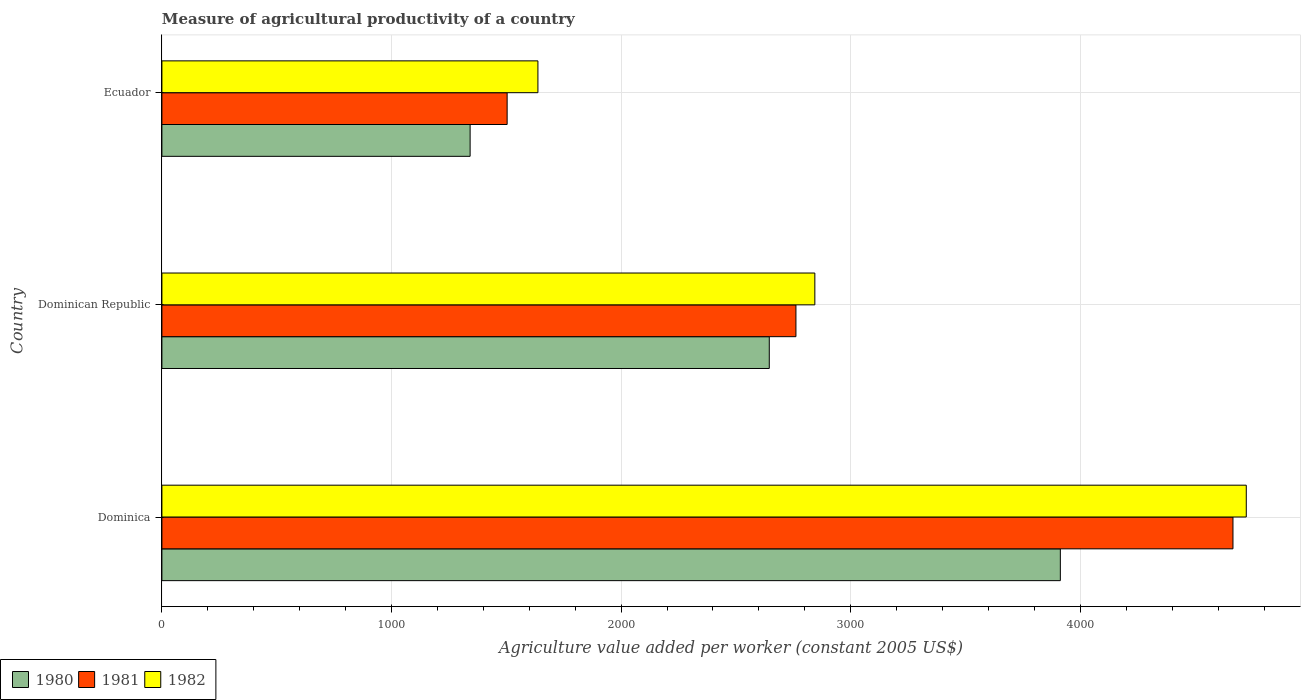How many groups of bars are there?
Offer a very short reply. 3. Are the number of bars on each tick of the Y-axis equal?
Provide a succinct answer. Yes. How many bars are there on the 2nd tick from the bottom?
Provide a short and direct response. 3. What is the label of the 3rd group of bars from the top?
Ensure brevity in your answer.  Dominica. What is the measure of agricultural productivity in 1981 in Ecuador?
Provide a succinct answer. 1503.63. Across all countries, what is the maximum measure of agricultural productivity in 1982?
Provide a succinct answer. 4722.8. Across all countries, what is the minimum measure of agricultural productivity in 1980?
Keep it short and to the point. 1342.41. In which country was the measure of agricultural productivity in 1982 maximum?
Offer a terse response. Dominica. In which country was the measure of agricultural productivity in 1980 minimum?
Give a very brief answer. Ecuador. What is the total measure of agricultural productivity in 1982 in the graph?
Offer a very short reply. 9204.29. What is the difference between the measure of agricultural productivity in 1980 in Dominica and that in Ecuador?
Offer a terse response. 2570.58. What is the difference between the measure of agricultural productivity in 1982 in Dominica and the measure of agricultural productivity in 1981 in Ecuador?
Make the answer very short. 3219.18. What is the average measure of agricultural productivity in 1982 per country?
Provide a short and direct response. 3068.1. What is the difference between the measure of agricultural productivity in 1982 and measure of agricultural productivity in 1981 in Dominican Republic?
Ensure brevity in your answer.  82.38. What is the ratio of the measure of agricultural productivity in 1981 in Dominica to that in Dominican Republic?
Your answer should be compact. 1.69. Is the measure of agricultural productivity in 1982 in Dominica less than that in Dominican Republic?
Give a very brief answer. No. Is the difference between the measure of agricultural productivity in 1982 in Dominica and Ecuador greater than the difference between the measure of agricultural productivity in 1981 in Dominica and Ecuador?
Offer a terse response. No. What is the difference between the highest and the second highest measure of agricultural productivity in 1980?
Ensure brevity in your answer.  1267.68. What is the difference between the highest and the lowest measure of agricultural productivity in 1981?
Provide a succinct answer. 3161.2. Is the sum of the measure of agricultural productivity in 1981 in Dominican Republic and Ecuador greater than the maximum measure of agricultural productivity in 1980 across all countries?
Your response must be concise. Yes. How many bars are there?
Your response must be concise. 9. How many countries are there in the graph?
Your answer should be very brief. 3. What is the difference between two consecutive major ticks on the X-axis?
Your response must be concise. 1000. Are the values on the major ticks of X-axis written in scientific E-notation?
Your answer should be very brief. No. Does the graph contain grids?
Offer a terse response. Yes. Where does the legend appear in the graph?
Provide a succinct answer. Bottom left. How many legend labels are there?
Keep it short and to the point. 3. What is the title of the graph?
Provide a succinct answer. Measure of agricultural productivity of a country. Does "1983" appear as one of the legend labels in the graph?
Make the answer very short. No. What is the label or title of the X-axis?
Make the answer very short. Agriculture value added per worker (constant 2005 US$). What is the label or title of the Y-axis?
Your answer should be very brief. Country. What is the Agriculture value added per worker (constant 2005 US$) of 1980 in Dominica?
Your answer should be very brief. 3912.99. What is the Agriculture value added per worker (constant 2005 US$) of 1981 in Dominica?
Provide a short and direct response. 4664.83. What is the Agriculture value added per worker (constant 2005 US$) in 1982 in Dominica?
Make the answer very short. 4722.8. What is the Agriculture value added per worker (constant 2005 US$) of 1980 in Dominican Republic?
Make the answer very short. 2645.31. What is the Agriculture value added per worker (constant 2005 US$) of 1981 in Dominican Republic?
Give a very brief answer. 2761.41. What is the Agriculture value added per worker (constant 2005 US$) in 1982 in Dominican Republic?
Offer a terse response. 2843.79. What is the Agriculture value added per worker (constant 2005 US$) in 1980 in Ecuador?
Keep it short and to the point. 1342.41. What is the Agriculture value added per worker (constant 2005 US$) of 1981 in Ecuador?
Keep it short and to the point. 1503.63. What is the Agriculture value added per worker (constant 2005 US$) in 1982 in Ecuador?
Make the answer very short. 1637.69. Across all countries, what is the maximum Agriculture value added per worker (constant 2005 US$) of 1980?
Ensure brevity in your answer.  3912.99. Across all countries, what is the maximum Agriculture value added per worker (constant 2005 US$) in 1981?
Give a very brief answer. 4664.83. Across all countries, what is the maximum Agriculture value added per worker (constant 2005 US$) of 1982?
Provide a short and direct response. 4722.8. Across all countries, what is the minimum Agriculture value added per worker (constant 2005 US$) in 1980?
Make the answer very short. 1342.41. Across all countries, what is the minimum Agriculture value added per worker (constant 2005 US$) in 1981?
Provide a short and direct response. 1503.63. Across all countries, what is the minimum Agriculture value added per worker (constant 2005 US$) of 1982?
Your response must be concise. 1637.69. What is the total Agriculture value added per worker (constant 2005 US$) of 1980 in the graph?
Provide a short and direct response. 7900.71. What is the total Agriculture value added per worker (constant 2005 US$) in 1981 in the graph?
Give a very brief answer. 8929.87. What is the total Agriculture value added per worker (constant 2005 US$) in 1982 in the graph?
Your response must be concise. 9204.29. What is the difference between the Agriculture value added per worker (constant 2005 US$) of 1980 in Dominica and that in Dominican Republic?
Offer a terse response. 1267.68. What is the difference between the Agriculture value added per worker (constant 2005 US$) of 1981 in Dominica and that in Dominican Republic?
Provide a succinct answer. 1903.42. What is the difference between the Agriculture value added per worker (constant 2005 US$) of 1982 in Dominica and that in Dominican Republic?
Your response must be concise. 1879.02. What is the difference between the Agriculture value added per worker (constant 2005 US$) of 1980 in Dominica and that in Ecuador?
Provide a short and direct response. 2570.58. What is the difference between the Agriculture value added per worker (constant 2005 US$) of 1981 in Dominica and that in Ecuador?
Give a very brief answer. 3161.2. What is the difference between the Agriculture value added per worker (constant 2005 US$) in 1982 in Dominica and that in Ecuador?
Offer a very short reply. 3085.11. What is the difference between the Agriculture value added per worker (constant 2005 US$) of 1980 in Dominican Republic and that in Ecuador?
Give a very brief answer. 1302.9. What is the difference between the Agriculture value added per worker (constant 2005 US$) in 1981 in Dominican Republic and that in Ecuador?
Provide a short and direct response. 1257.78. What is the difference between the Agriculture value added per worker (constant 2005 US$) in 1982 in Dominican Republic and that in Ecuador?
Your response must be concise. 1206.1. What is the difference between the Agriculture value added per worker (constant 2005 US$) in 1980 in Dominica and the Agriculture value added per worker (constant 2005 US$) in 1981 in Dominican Republic?
Ensure brevity in your answer.  1151.58. What is the difference between the Agriculture value added per worker (constant 2005 US$) of 1980 in Dominica and the Agriculture value added per worker (constant 2005 US$) of 1982 in Dominican Republic?
Provide a succinct answer. 1069.2. What is the difference between the Agriculture value added per worker (constant 2005 US$) of 1981 in Dominica and the Agriculture value added per worker (constant 2005 US$) of 1982 in Dominican Republic?
Give a very brief answer. 1821.04. What is the difference between the Agriculture value added per worker (constant 2005 US$) in 1980 in Dominica and the Agriculture value added per worker (constant 2005 US$) in 1981 in Ecuador?
Provide a short and direct response. 2409.36. What is the difference between the Agriculture value added per worker (constant 2005 US$) of 1980 in Dominica and the Agriculture value added per worker (constant 2005 US$) of 1982 in Ecuador?
Keep it short and to the point. 2275.3. What is the difference between the Agriculture value added per worker (constant 2005 US$) in 1981 in Dominica and the Agriculture value added per worker (constant 2005 US$) in 1982 in Ecuador?
Give a very brief answer. 3027.14. What is the difference between the Agriculture value added per worker (constant 2005 US$) of 1980 in Dominican Republic and the Agriculture value added per worker (constant 2005 US$) of 1981 in Ecuador?
Your answer should be very brief. 1141.68. What is the difference between the Agriculture value added per worker (constant 2005 US$) of 1980 in Dominican Republic and the Agriculture value added per worker (constant 2005 US$) of 1982 in Ecuador?
Provide a succinct answer. 1007.62. What is the difference between the Agriculture value added per worker (constant 2005 US$) of 1981 in Dominican Republic and the Agriculture value added per worker (constant 2005 US$) of 1982 in Ecuador?
Give a very brief answer. 1123.72. What is the average Agriculture value added per worker (constant 2005 US$) in 1980 per country?
Offer a very short reply. 2633.57. What is the average Agriculture value added per worker (constant 2005 US$) of 1981 per country?
Provide a short and direct response. 2976.62. What is the average Agriculture value added per worker (constant 2005 US$) in 1982 per country?
Offer a very short reply. 3068.1. What is the difference between the Agriculture value added per worker (constant 2005 US$) in 1980 and Agriculture value added per worker (constant 2005 US$) in 1981 in Dominica?
Your answer should be very brief. -751.84. What is the difference between the Agriculture value added per worker (constant 2005 US$) of 1980 and Agriculture value added per worker (constant 2005 US$) of 1982 in Dominica?
Provide a short and direct response. -809.81. What is the difference between the Agriculture value added per worker (constant 2005 US$) of 1981 and Agriculture value added per worker (constant 2005 US$) of 1982 in Dominica?
Your answer should be compact. -57.97. What is the difference between the Agriculture value added per worker (constant 2005 US$) of 1980 and Agriculture value added per worker (constant 2005 US$) of 1981 in Dominican Republic?
Offer a terse response. -116.1. What is the difference between the Agriculture value added per worker (constant 2005 US$) of 1980 and Agriculture value added per worker (constant 2005 US$) of 1982 in Dominican Republic?
Your response must be concise. -198.48. What is the difference between the Agriculture value added per worker (constant 2005 US$) in 1981 and Agriculture value added per worker (constant 2005 US$) in 1982 in Dominican Republic?
Keep it short and to the point. -82.38. What is the difference between the Agriculture value added per worker (constant 2005 US$) in 1980 and Agriculture value added per worker (constant 2005 US$) in 1981 in Ecuador?
Provide a short and direct response. -161.22. What is the difference between the Agriculture value added per worker (constant 2005 US$) in 1980 and Agriculture value added per worker (constant 2005 US$) in 1982 in Ecuador?
Provide a succinct answer. -295.29. What is the difference between the Agriculture value added per worker (constant 2005 US$) in 1981 and Agriculture value added per worker (constant 2005 US$) in 1982 in Ecuador?
Give a very brief answer. -134.06. What is the ratio of the Agriculture value added per worker (constant 2005 US$) of 1980 in Dominica to that in Dominican Republic?
Ensure brevity in your answer.  1.48. What is the ratio of the Agriculture value added per worker (constant 2005 US$) of 1981 in Dominica to that in Dominican Republic?
Your answer should be very brief. 1.69. What is the ratio of the Agriculture value added per worker (constant 2005 US$) in 1982 in Dominica to that in Dominican Republic?
Your response must be concise. 1.66. What is the ratio of the Agriculture value added per worker (constant 2005 US$) of 1980 in Dominica to that in Ecuador?
Provide a succinct answer. 2.91. What is the ratio of the Agriculture value added per worker (constant 2005 US$) in 1981 in Dominica to that in Ecuador?
Your response must be concise. 3.1. What is the ratio of the Agriculture value added per worker (constant 2005 US$) in 1982 in Dominica to that in Ecuador?
Offer a terse response. 2.88. What is the ratio of the Agriculture value added per worker (constant 2005 US$) of 1980 in Dominican Republic to that in Ecuador?
Your answer should be very brief. 1.97. What is the ratio of the Agriculture value added per worker (constant 2005 US$) in 1981 in Dominican Republic to that in Ecuador?
Your response must be concise. 1.84. What is the ratio of the Agriculture value added per worker (constant 2005 US$) in 1982 in Dominican Republic to that in Ecuador?
Your response must be concise. 1.74. What is the difference between the highest and the second highest Agriculture value added per worker (constant 2005 US$) of 1980?
Provide a succinct answer. 1267.68. What is the difference between the highest and the second highest Agriculture value added per worker (constant 2005 US$) of 1981?
Your answer should be very brief. 1903.42. What is the difference between the highest and the second highest Agriculture value added per worker (constant 2005 US$) in 1982?
Give a very brief answer. 1879.02. What is the difference between the highest and the lowest Agriculture value added per worker (constant 2005 US$) in 1980?
Offer a very short reply. 2570.58. What is the difference between the highest and the lowest Agriculture value added per worker (constant 2005 US$) of 1981?
Keep it short and to the point. 3161.2. What is the difference between the highest and the lowest Agriculture value added per worker (constant 2005 US$) of 1982?
Keep it short and to the point. 3085.11. 